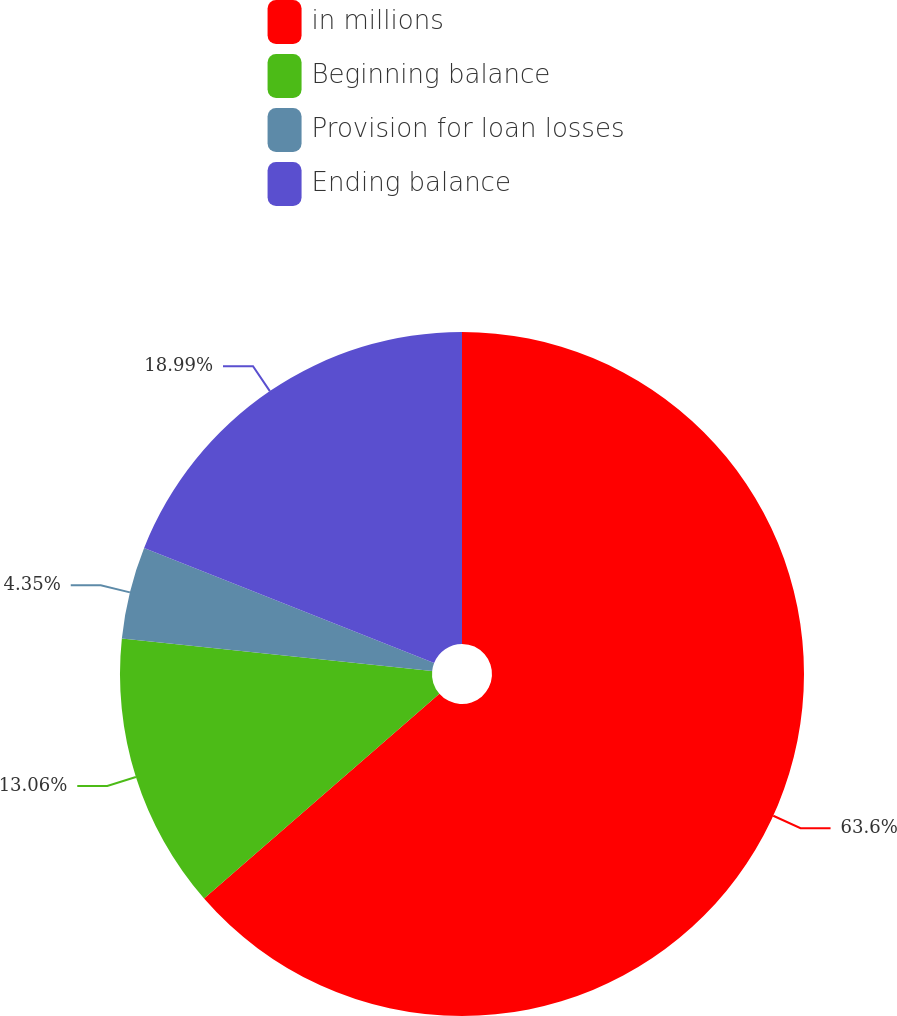Convert chart. <chart><loc_0><loc_0><loc_500><loc_500><pie_chart><fcel>in millions<fcel>Beginning balance<fcel>Provision for loan losses<fcel>Ending balance<nl><fcel>63.6%<fcel>13.06%<fcel>4.35%<fcel>18.99%<nl></chart> 